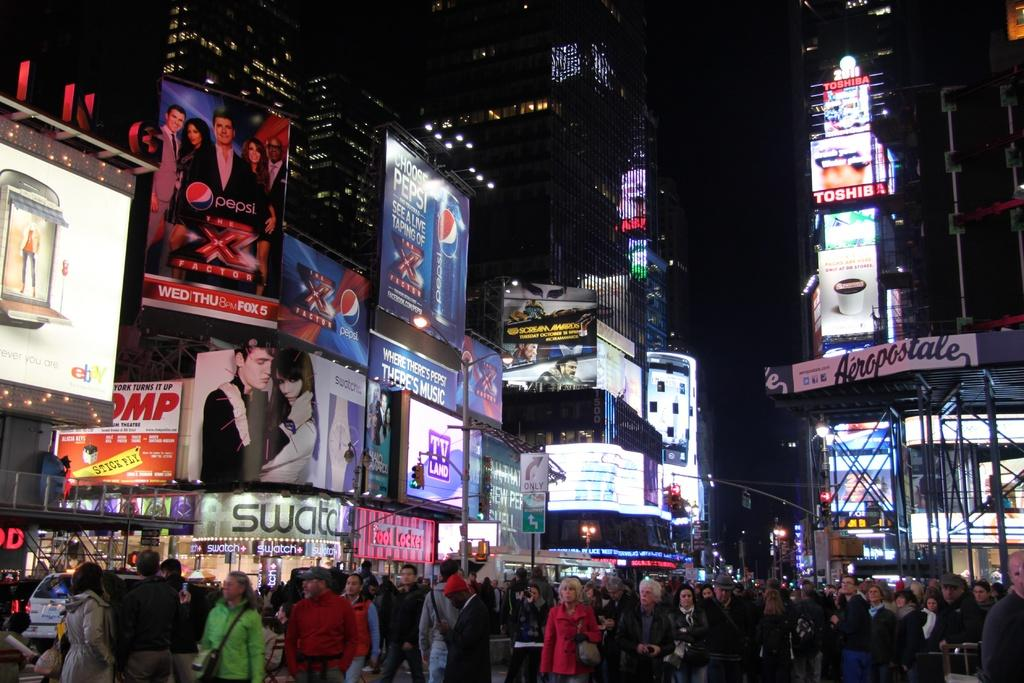What are the people in the image doing? The people in the image are walking on the streets. What else can be seen on the streets besides people? There are cars in the image. What type of information might be conveyed by the sign boards in the image? The sign boards in the image might convey information about directions, rules, or advertisements. What type of structures are visible in the image? There are buildings in the image. What can be seen on the buildings in the image? There are billboards on the buildings. What type of treatment is being administered to the wire in the image? There is no wire present in the image, so no treatment is being administered. What type of coil is visible on the buildings in the image? There are no coils visible on the buildings in the image; only billboards are present. 